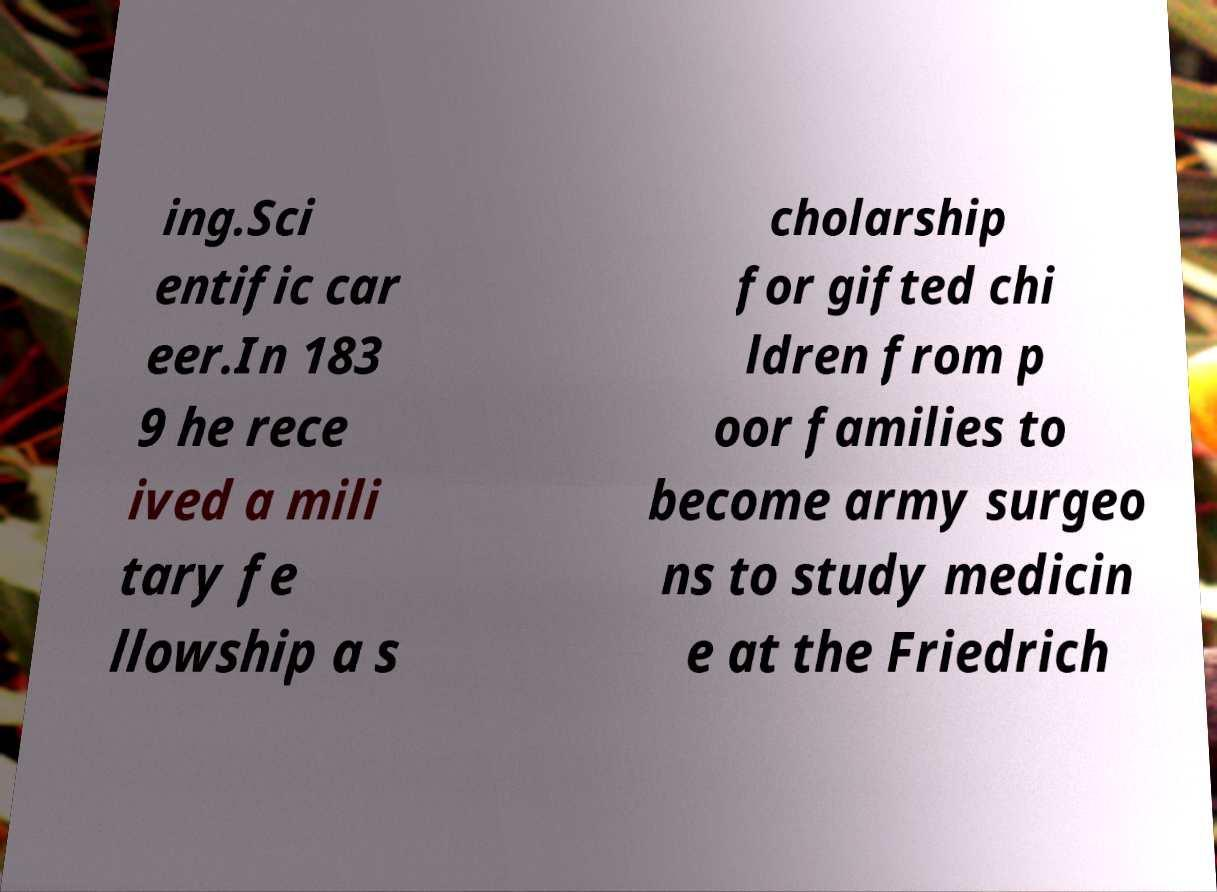Please read and relay the text visible in this image. What does it say? ing.Sci entific car eer.In 183 9 he rece ived a mili tary fe llowship a s cholarship for gifted chi ldren from p oor families to become army surgeo ns to study medicin e at the Friedrich 